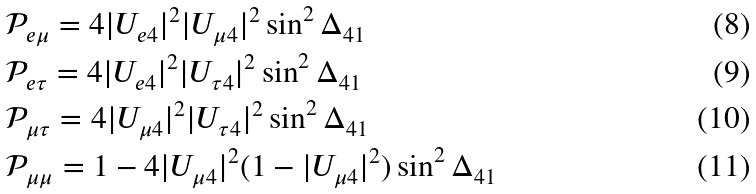<formula> <loc_0><loc_0><loc_500><loc_500>& \mathcal { P } _ { e \mu } = 4 | U _ { e 4 } | ^ { 2 } | U _ { \mu 4 } | ^ { 2 } \sin ^ { 2 } \Delta _ { 4 1 } \\ & \mathcal { P } _ { e \tau } = 4 | U _ { e 4 } | ^ { 2 } | U _ { \tau 4 } | ^ { 2 } \sin ^ { 2 } \Delta _ { 4 1 } \\ & \mathcal { P } _ { \mu \tau } = 4 | U _ { \mu 4 } | ^ { 2 } | U _ { \tau 4 } | ^ { 2 } \sin ^ { 2 } \Delta _ { 4 1 } \\ & \mathcal { P } _ { \mu \mu } = 1 - 4 | U _ { \mu 4 } | ^ { 2 } ( 1 - | U _ { \mu 4 } | ^ { 2 } ) \sin ^ { 2 } \Delta _ { 4 1 }</formula> 